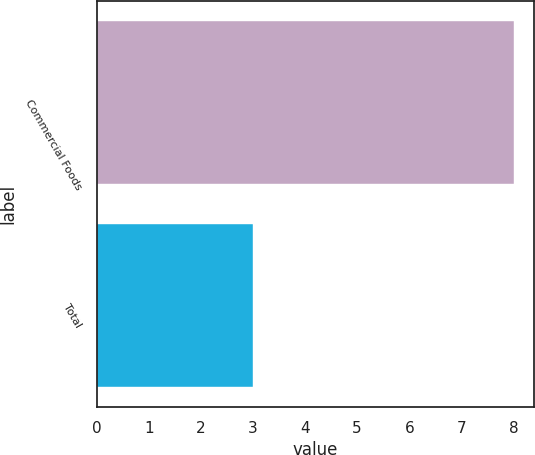Convert chart to OTSL. <chart><loc_0><loc_0><loc_500><loc_500><bar_chart><fcel>Commercial Foods<fcel>Total<nl><fcel>8<fcel>3<nl></chart> 